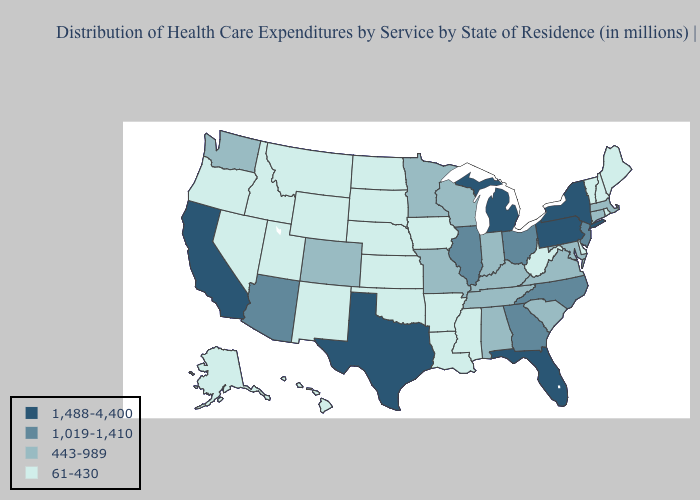Does Arkansas have a lower value than New Hampshire?
Be succinct. No. What is the lowest value in the USA?
Write a very short answer. 61-430. Does Arizona have a higher value than Florida?
Short answer required. No. What is the lowest value in states that border New Mexico?
Keep it brief. 61-430. Name the states that have a value in the range 1,019-1,410?
Answer briefly. Arizona, Georgia, Illinois, New Jersey, North Carolina, Ohio. Does South Dakota have a higher value than West Virginia?
Short answer required. No. Which states have the highest value in the USA?
Write a very short answer. California, Florida, Michigan, New York, Pennsylvania, Texas. What is the highest value in the USA?
Keep it brief. 1,488-4,400. Among the states that border Ohio , does West Virginia have the highest value?
Keep it brief. No. Which states have the lowest value in the USA?
Give a very brief answer. Alaska, Arkansas, Delaware, Hawaii, Idaho, Iowa, Kansas, Louisiana, Maine, Mississippi, Montana, Nebraska, Nevada, New Hampshire, New Mexico, North Dakota, Oklahoma, Oregon, Rhode Island, South Dakota, Utah, Vermont, West Virginia, Wyoming. Does New York have a higher value than Pennsylvania?
Quick response, please. No. Name the states that have a value in the range 443-989?
Keep it brief. Alabama, Colorado, Connecticut, Indiana, Kentucky, Maryland, Massachusetts, Minnesota, Missouri, South Carolina, Tennessee, Virginia, Washington, Wisconsin. Does South Dakota have the lowest value in the USA?
Quick response, please. Yes. What is the lowest value in the USA?
Be succinct. 61-430. Does Florida have the highest value in the USA?
Be succinct. Yes. 